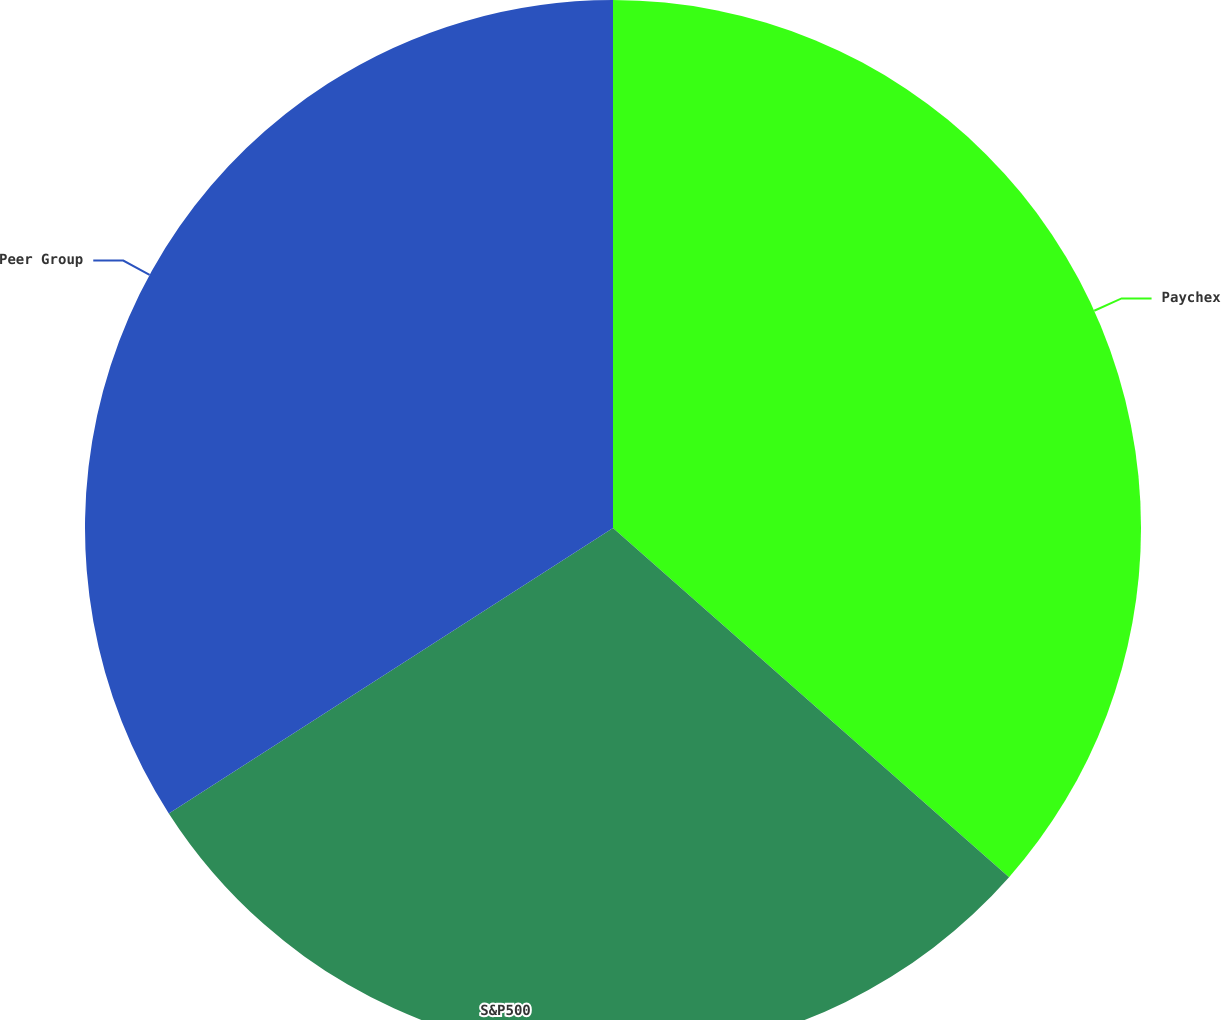<chart> <loc_0><loc_0><loc_500><loc_500><pie_chart><fcel>Paychex<fcel>S&P500<fcel>Peer Group<nl><fcel>36.5%<fcel>29.41%<fcel>34.09%<nl></chart> 